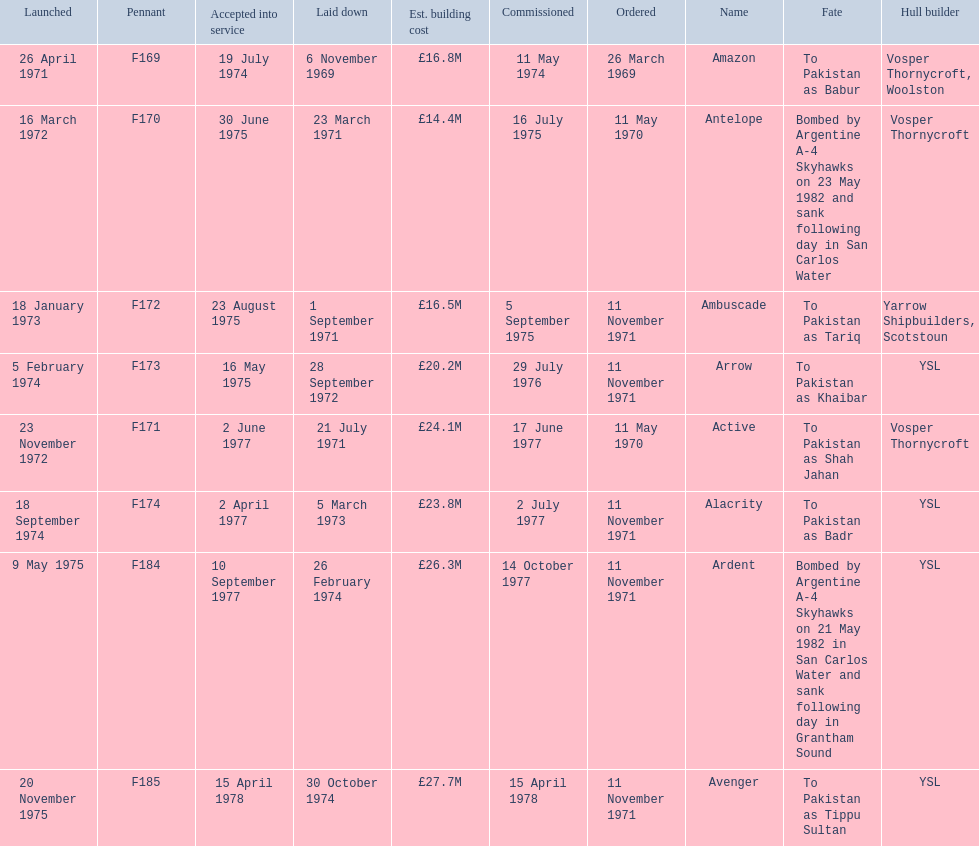Which ships cost more than ps25.0m to build? Ardent, Avenger. Of the ships listed in the answer above, which one cost the most to build? Avenger. 